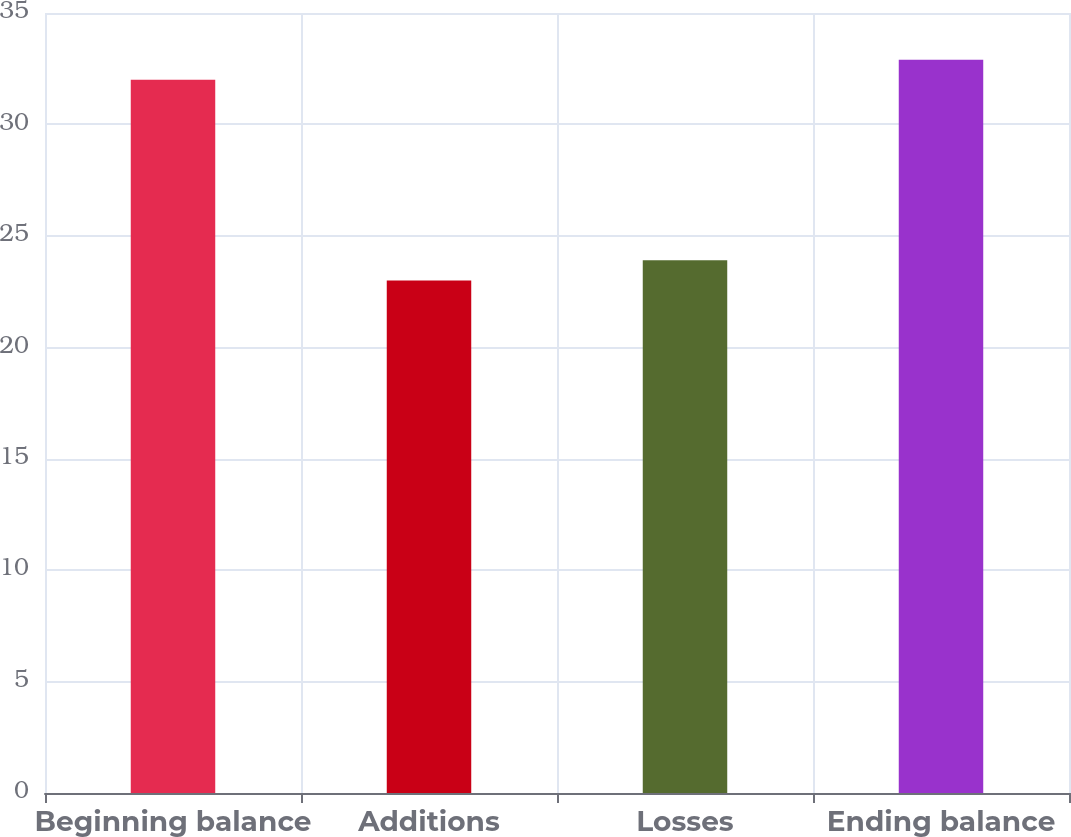<chart> <loc_0><loc_0><loc_500><loc_500><bar_chart><fcel>Beginning balance<fcel>Additions<fcel>Losses<fcel>Ending balance<nl><fcel>32<fcel>23<fcel>23.9<fcel>32.9<nl></chart> 